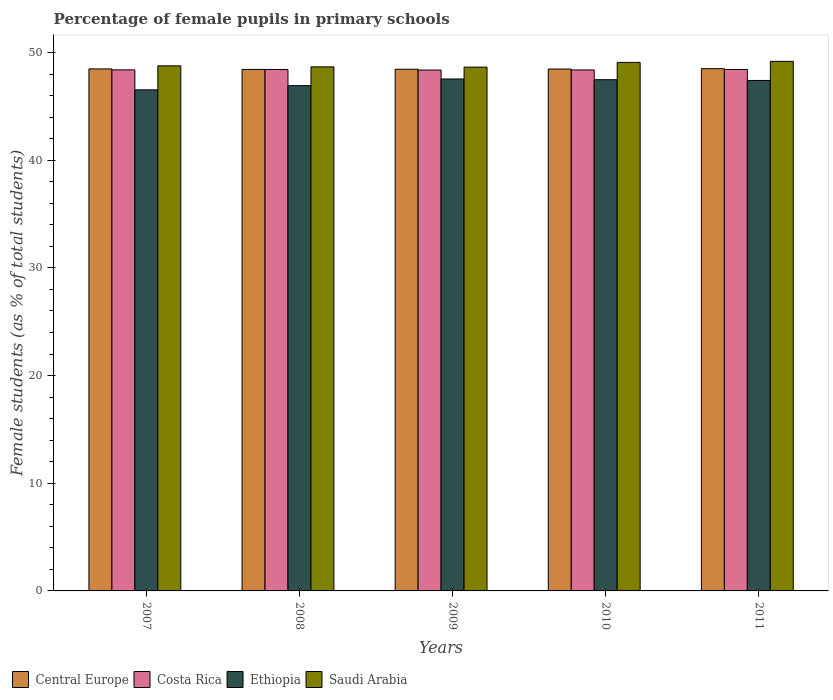How many different coloured bars are there?
Your answer should be compact. 4. How many groups of bars are there?
Make the answer very short. 5. Are the number of bars on each tick of the X-axis equal?
Ensure brevity in your answer.  Yes. In how many cases, is the number of bars for a given year not equal to the number of legend labels?
Give a very brief answer. 0. What is the percentage of female pupils in primary schools in Saudi Arabia in 2011?
Provide a succinct answer. 49.18. Across all years, what is the maximum percentage of female pupils in primary schools in Saudi Arabia?
Provide a succinct answer. 49.18. Across all years, what is the minimum percentage of female pupils in primary schools in Ethiopia?
Offer a very short reply. 46.53. In which year was the percentage of female pupils in primary schools in Central Europe maximum?
Your response must be concise. 2011. In which year was the percentage of female pupils in primary schools in Saudi Arabia minimum?
Keep it short and to the point. 2009. What is the total percentage of female pupils in primary schools in Costa Rica in the graph?
Offer a very short reply. 241.98. What is the difference between the percentage of female pupils in primary schools in Central Europe in 2009 and that in 2010?
Provide a short and direct response. -0.02. What is the difference between the percentage of female pupils in primary schools in Saudi Arabia in 2007 and the percentage of female pupils in primary schools in Central Europe in 2008?
Your response must be concise. 0.34. What is the average percentage of female pupils in primary schools in Ethiopia per year?
Ensure brevity in your answer.  47.17. In the year 2010, what is the difference between the percentage of female pupils in primary schools in Ethiopia and percentage of female pupils in primary schools in Costa Rica?
Offer a very short reply. -0.9. In how many years, is the percentage of female pupils in primary schools in Saudi Arabia greater than 40 %?
Your answer should be compact. 5. What is the ratio of the percentage of female pupils in primary schools in Costa Rica in 2010 to that in 2011?
Ensure brevity in your answer.  1. Is the difference between the percentage of female pupils in primary schools in Ethiopia in 2008 and 2009 greater than the difference between the percentage of female pupils in primary schools in Costa Rica in 2008 and 2009?
Give a very brief answer. No. What is the difference between the highest and the second highest percentage of female pupils in primary schools in Central Europe?
Your response must be concise. 0.02. What is the difference between the highest and the lowest percentage of female pupils in primary schools in Costa Rica?
Your answer should be compact. 0.05. In how many years, is the percentage of female pupils in primary schools in Saudi Arabia greater than the average percentage of female pupils in primary schools in Saudi Arabia taken over all years?
Ensure brevity in your answer.  2. Is the sum of the percentage of female pupils in primary schools in Central Europe in 2008 and 2009 greater than the maximum percentage of female pupils in primary schools in Saudi Arabia across all years?
Ensure brevity in your answer.  Yes. Is it the case that in every year, the sum of the percentage of female pupils in primary schools in Saudi Arabia and percentage of female pupils in primary schools in Costa Rica is greater than the sum of percentage of female pupils in primary schools in Central Europe and percentage of female pupils in primary schools in Ethiopia?
Provide a short and direct response. Yes. What does the 4th bar from the left in 2008 represents?
Give a very brief answer. Saudi Arabia. Is it the case that in every year, the sum of the percentage of female pupils in primary schools in Central Europe and percentage of female pupils in primary schools in Saudi Arabia is greater than the percentage of female pupils in primary schools in Ethiopia?
Offer a very short reply. Yes. What is the difference between two consecutive major ticks on the Y-axis?
Provide a succinct answer. 10. Does the graph contain grids?
Ensure brevity in your answer.  No. How many legend labels are there?
Your response must be concise. 4. How are the legend labels stacked?
Offer a terse response. Horizontal. What is the title of the graph?
Your answer should be compact. Percentage of female pupils in primary schools. Does "Mexico" appear as one of the legend labels in the graph?
Provide a succinct answer. No. What is the label or title of the Y-axis?
Your response must be concise. Female students (as % of total students). What is the Female students (as % of total students) in Central Europe in 2007?
Ensure brevity in your answer.  48.47. What is the Female students (as % of total students) of Costa Rica in 2007?
Your answer should be compact. 48.39. What is the Female students (as % of total students) of Ethiopia in 2007?
Keep it short and to the point. 46.53. What is the Female students (as % of total students) of Saudi Arabia in 2007?
Your answer should be very brief. 48.76. What is the Female students (as % of total students) in Central Europe in 2008?
Your response must be concise. 48.42. What is the Female students (as % of total students) of Costa Rica in 2008?
Offer a terse response. 48.42. What is the Female students (as % of total students) of Ethiopia in 2008?
Keep it short and to the point. 46.92. What is the Female students (as % of total students) in Saudi Arabia in 2008?
Offer a terse response. 48.66. What is the Female students (as % of total students) in Central Europe in 2009?
Your answer should be very brief. 48.44. What is the Female students (as % of total students) of Costa Rica in 2009?
Your answer should be compact. 48.37. What is the Female students (as % of total students) in Ethiopia in 2009?
Your answer should be very brief. 47.54. What is the Female students (as % of total students) in Saudi Arabia in 2009?
Offer a very short reply. 48.64. What is the Female students (as % of total students) in Central Europe in 2010?
Provide a succinct answer. 48.46. What is the Female students (as % of total students) of Costa Rica in 2010?
Your answer should be very brief. 48.38. What is the Female students (as % of total students) of Ethiopia in 2010?
Your response must be concise. 47.47. What is the Female students (as % of total students) in Saudi Arabia in 2010?
Your response must be concise. 49.08. What is the Female students (as % of total students) of Central Europe in 2011?
Offer a terse response. 48.5. What is the Female students (as % of total students) of Costa Rica in 2011?
Provide a succinct answer. 48.42. What is the Female students (as % of total students) of Ethiopia in 2011?
Your response must be concise. 47.4. What is the Female students (as % of total students) of Saudi Arabia in 2011?
Make the answer very short. 49.18. Across all years, what is the maximum Female students (as % of total students) in Central Europe?
Your answer should be compact. 48.5. Across all years, what is the maximum Female students (as % of total students) of Costa Rica?
Give a very brief answer. 48.42. Across all years, what is the maximum Female students (as % of total students) in Ethiopia?
Keep it short and to the point. 47.54. Across all years, what is the maximum Female students (as % of total students) in Saudi Arabia?
Offer a very short reply. 49.18. Across all years, what is the minimum Female students (as % of total students) of Central Europe?
Offer a terse response. 48.42. Across all years, what is the minimum Female students (as % of total students) in Costa Rica?
Your response must be concise. 48.37. Across all years, what is the minimum Female students (as % of total students) of Ethiopia?
Provide a succinct answer. 46.53. Across all years, what is the minimum Female students (as % of total students) of Saudi Arabia?
Your answer should be compact. 48.64. What is the total Female students (as % of total students) in Central Europe in the graph?
Give a very brief answer. 242.3. What is the total Female students (as % of total students) of Costa Rica in the graph?
Provide a succinct answer. 241.98. What is the total Female students (as % of total students) in Ethiopia in the graph?
Offer a very short reply. 235.87. What is the total Female students (as % of total students) of Saudi Arabia in the graph?
Make the answer very short. 244.32. What is the difference between the Female students (as % of total students) of Central Europe in 2007 and that in 2008?
Your answer should be very brief. 0.05. What is the difference between the Female students (as % of total students) of Costa Rica in 2007 and that in 2008?
Your answer should be compact. -0.04. What is the difference between the Female students (as % of total students) of Ethiopia in 2007 and that in 2008?
Give a very brief answer. -0.39. What is the difference between the Female students (as % of total students) of Saudi Arabia in 2007 and that in 2008?
Your answer should be compact. 0.1. What is the difference between the Female students (as % of total students) of Central Europe in 2007 and that in 2009?
Offer a terse response. 0.03. What is the difference between the Female students (as % of total students) of Costa Rica in 2007 and that in 2009?
Give a very brief answer. 0.01. What is the difference between the Female students (as % of total students) of Ethiopia in 2007 and that in 2009?
Your answer should be very brief. -1.01. What is the difference between the Female students (as % of total students) of Saudi Arabia in 2007 and that in 2009?
Provide a short and direct response. 0.12. What is the difference between the Female students (as % of total students) in Central Europe in 2007 and that in 2010?
Provide a short and direct response. 0.01. What is the difference between the Female students (as % of total students) of Costa Rica in 2007 and that in 2010?
Give a very brief answer. 0.01. What is the difference between the Female students (as % of total students) in Ethiopia in 2007 and that in 2010?
Ensure brevity in your answer.  -0.94. What is the difference between the Female students (as % of total students) in Saudi Arabia in 2007 and that in 2010?
Provide a short and direct response. -0.32. What is the difference between the Female students (as % of total students) of Central Europe in 2007 and that in 2011?
Your answer should be compact. -0.02. What is the difference between the Female students (as % of total students) in Costa Rica in 2007 and that in 2011?
Give a very brief answer. -0.04. What is the difference between the Female students (as % of total students) of Ethiopia in 2007 and that in 2011?
Ensure brevity in your answer.  -0.87. What is the difference between the Female students (as % of total students) of Saudi Arabia in 2007 and that in 2011?
Your response must be concise. -0.42. What is the difference between the Female students (as % of total students) in Central Europe in 2008 and that in 2009?
Your answer should be compact. -0.02. What is the difference between the Female students (as % of total students) in Costa Rica in 2008 and that in 2009?
Provide a succinct answer. 0.05. What is the difference between the Female students (as % of total students) in Ethiopia in 2008 and that in 2009?
Make the answer very short. -0.62. What is the difference between the Female students (as % of total students) of Saudi Arabia in 2008 and that in 2009?
Offer a terse response. 0.02. What is the difference between the Female students (as % of total students) in Central Europe in 2008 and that in 2010?
Offer a very short reply. -0.04. What is the difference between the Female students (as % of total students) in Costa Rica in 2008 and that in 2010?
Your answer should be compact. 0.05. What is the difference between the Female students (as % of total students) in Ethiopia in 2008 and that in 2010?
Provide a short and direct response. -0.55. What is the difference between the Female students (as % of total students) in Saudi Arabia in 2008 and that in 2010?
Provide a succinct answer. -0.42. What is the difference between the Female students (as % of total students) in Central Europe in 2008 and that in 2011?
Your response must be concise. -0.07. What is the difference between the Female students (as % of total students) of Costa Rica in 2008 and that in 2011?
Offer a terse response. 0. What is the difference between the Female students (as % of total students) of Ethiopia in 2008 and that in 2011?
Ensure brevity in your answer.  -0.48. What is the difference between the Female students (as % of total students) of Saudi Arabia in 2008 and that in 2011?
Offer a very short reply. -0.51. What is the difference between the Female students (as % of total students) of Central Europe in 2009 and that in 2010?
Your answer should be very brief. -0.02. What is the difference between the Female students (as % of total students) in Costa Rica in 2009 and that in 2010?
Keep it short and to the point. -0.01. What is the difference between the Female students (as % of total students) in Ethiopia in 2009 and that in 2010?
Make the answer very short. 0.07. What is the difference between the Female students (as % of total students) in Saudi Arabia in 2009 and that in 2010?
Make the answer very short. -0.44. What is the difference between the Female students (as % of total students) in Central Europe in 2009 and that in 2011?
Your answer should be compact. -0.05. What is the difference between the Female students (as % of total students) in Costa Rica in 2009 and that in 2011?
Give a very brief answer. -0.05. What is the difference between the Female students (as % of total students) of Ethiopia in 2009 and that in 2011?
Your response must be concise. 0.14. What is the difference between the Female students (as % of total students) of Saudi Arabia in 2009 and that in 2011?
Offer a very short reply. -0.54. What is the difference between the Female students (as % of total students) in Central Europe in 2010 and that in 2011?
Offer a very short reply. -0.03. What is the difference between the Female students (as % of total students) of Costa Rica in 2010 and that in 2011?
Your answer should be compact. -0.04. What is the difference between the Female students (as % of total students) of Ethiopia in 2010 and that in 2011?
Offer a very short reply. 0.07. What is the difference between the Female students (as % of total students) in Saudi Arabia in 2010 and that in 2011?
Your response must be concise. -0.1. What is the difference between the Female students (as % of total students) of Central Europe in 2007 and the Female students (as % of total students) of Costa Rica in 2008?
Your response must be concise. 0.05. What is the difference between the Female students (as % of total students) in Central Europe in 2007 and the Female students (as % of total students) in Ethiopia in 2008?
Your response must be concise. 1.55. What is the difference between the Female students (as % of total students) of Central Europe in 2007 and the Female students (as % of total students) of Saudi Arabia in 2008?
Keep it short and to the point. -0.19. What is the difference between the Female students (as % of total students) in Costa Rica in 2007 and the Female students (as % of total students) in Ethiopia in 2008?
Your response must be concise. 1.47. What is the difference between the Female students (as % of total students) in Costa Rica in 2007 and the Female students (as % of total students) in Saudi Arabia in 2008?
Give a very brief answer. -0.28. What is the difference between the Female students (as % of total students) in Ethiopia in 2007 and the Female students (as % of total students) in Saudi Arabia in 2008?
Provide a succinct answer. -2.13. What is the difference between the Female students (as % of total students) in Central Europe in 2007 and the Female students (as % of total students) in Costa Rica in 2009?
Ensure brevity in your answer.  0.1. What is the difference between the Female students (as % of total students) of Central Europe in 2007 and the Female students (as % of total students) of Ethiopia in 2009?
Your answer should be very brief. 0.93. What is the difference between the Female students (as % of total students) in Central Europe in 2007 and the Female students (as % of total students) in Saudi Arabia in 2009?
Ensure brevity in your answer.  -0.17. What is the difference between the Female students (as % of total students) in Costa Rica in 2007 and the Female students (as % of total students) in Ethiopia in 2009?
Ensure brevity in your answer.  0.85. What is the difference between the Female students (as % of total students) in Costa Rica in 2007 and the Female students (as % of total students) in Saudi Arabia in 2009?
Offer a very short reply. -0.26. What is the difference between the Female students (as % of total students) in Ethiopia in 2007 and the Female students (as % of total students) in Saudi Arabia in 2009?
Offer a very short reply. -2.11. What is the difference between the Female students (as % of total students) of Central Europe in 2007 and the Female students (as % of total students) of Costa Rica in 2010?
Ensure brevity in your answer.  0.1. What is the difference between the Female students (as % of total students) of Central Europe in 2007 and the Female students (as % of total students) of Ethiopia in 2010?
Keep it short and to the point. 1. What is the difference between the Female students (as % of total students) in Central Europe in 2007 and the Female students (as % of total students) in Saudi Arabia in 2010?
Make the answer very short. -0.61. What is the difference between the Female students (as % of total students) in Costa Rica in 2007 and the Female students (as % of total students) in Ethiopia in 2010?
Your answer should be very brief. 0.91. What is the difference between the Female students (as % of total students) of Costa Rica in 2007 and the Female students (as % of total students) of Saudi Arabia in 2010?
Your answer should be compact. -0.69. What is the difference between the Female students (as % of total students) of Ethiopia in 2007 and the Female students (as % of total students) of Saudi Arabia in 2010?
Your answer should be compact. -2.55. What is the difference between the Female students (as % of total students) of Central Europe in 2007 and the Female students (as % of total students) of Costa Rica in 2011?
Your answer should be very brief. 0.05. What is the difference between the Female students (as % of total students) of Central Europe in 2007 and the Female students (as % of total students) of Ethiopia in 2011?
Your answer should be very brief. 1.07. What is the difference between the Female students (as % of total students) of Central Europe in 2007 and the Female students (as % of total students) of Saudi Arabia in 2011?
Ensure brevity in your answer.  -0.7. What is the difference between the Female students (as % of total students) of Costa Rica in 2007 and the Female students (as % of total students) of Ethiopia in 2011?
Provide a succinct answer. 0.98. What is the difference between the Female students (as % of total students) of Costa Rica in 2007 and the Female students (as % of total students) of Saudi Arabia in 2011?
Keep it short and to the point. -0.79. What is the difference between the Female students (as % of total students) in Ethiopia in 2007 and the Female students (as % of total students) in Saudi Arabia in 2011?
Your response must be concise. -2.64. What is the difference between the Female students (as % of total students) in Central Europe in 2008 and the Female students (as % of total students) in Costa Rica in 2009?
Make the answer very short. 0.05. What is the difference between the Female students (as % of total students) in Central Europe in 2008 and the Female students (as % of total students) in Ethiopia in 2009?
Make the answer very short. 0.88. What is the difference between the Female students (as % of total students) in Central Europe in 2008 and the Female students (as % of total students) in Saudi Arabia in 2009?
Give a very brief answer. -0.22. What is the difference between the Female students (as % of total students) in Costa Rica in 2008 and the Female students (as % of total students) in Ethiopia in 2009?
Offer a terse response. 0.88. What is the difference between the Female students (as % of total students) in Costa Rica in 2008 and the Female students (as % of total students) in Saudi Arabia in 2009?
Keep it short and to the point. -0.22. What is the difference between the Female students (as % of total students) in Ethiopia in 2008 and the Female students (as % of total students) in Saudi Arabia in 2009?
Offer a very short reply. -1.72. What is the difference between the Female students (as % of total students) in Central Europe in 2008 and the Female students (as % of total students) in Costa Rica in 2010?
Keep it short and to the point. 0.05. What is the difference between the Female students (as % of total students) of Central Europe in 2008 and the Female students (as % of total students) of Ethiopia in 2010?
Your answer should be compact. 0.95. What is the difference between the Female students (as % of total students) in Central Europe in 2008 and the Female students (as % of total students) in Saudi Arabia in 2010?
Provide a succinct answer. -0.65. What is the difference between the Female students (as % of total students) in Costa Rica in 2008 and the Female students (as % of total students) in Ethiopia in 2010?
Your answer should be very brief. 0.95. What is the difference between the Female students (as % of total students) in Costa Rica in 2008 and the Female students (as % of total students) in Saudi Arabia in 2010?
Your answer should be compact. -0.66. What is the difference between the Female students (as % of total students) in Ethiopia in 2008 and the Female students (as % of total students) in Saudi Arabia in 2010?
Your answer should be very brief. -2.16. What is the difference between the Female students (as % of total students) in Central Europe in 2008 and the Female students (as % of total students) in Costa Rica in 2011?
Offer a very short reply. 0. What is the difference between the Female students (as % of total students) of Central Europe in 2008 and the Female students (as % of total students) of Ethiopia in 2011?
Your response must be concise. 1.02. What is the difference between the Female students (as % of total students) of Central Europe in 2008 and the Female students (as % of total students) of Saudi Arabia in 2011?
Your answer should be compact. -0.75. What is the difference between the Female students (as % of total students) in Costa Rica in 2008 and the Female students (as % of total students) in Ethiopia in 2011?
Your answer should be compact. 1.02. What is the difference between the Female students (as % of total students) of Costa Rica in 2008 and the Female students (as % of total students) of Saudi Arabia in 2011?
Your response must be concise. -0.75. What is the difference between the Female students (as % of total students) in Ethiopia in 2008 and the Female students (as % of total students) in Saudi Arabia in 2011?
Offer a terse response. -2.26. What is the difference between the Female students (as % of total students) of Central Europe in 2009 and the Female students (as % of total students) of Costa Rica in 2010?
Provide a succinct answer. 0.07. What is the difference between the Female students (as % of total students) of Central Europe in 2009 and the Female students (as % of total students) of Ethiopia in 2010?
Your response must be concise. 0.97. What is the difference between the Female students (as % of total students) in Central Europe in 2009 and the Female students (as % of total students) in Saudi Arabia in 2010?
Your answer should be very brief. -0.64. What is the difference between the Female students (as % of total students) of Costa Rica in 2009 and the Female students (as % of total students) of Ethiopia in 2010?
Your answer should be compact. 0.9. What is the difference between the Female students (as % of total students) in Costa Rica in 2009 and the Female students (as % of total students) in Saudi Arabia in 2010?
Your response must be concise. -0.71. What is the difference between the Female students (as % of total students) of Ethiopia in 2009 and the Female students (as % of total students) of Saudi Arabia in 2010?
Your answer should be compact. -1.54. What is the difference between the Female students (as % of total students) in Central Europe in 2009 and the Female students (as % of total students) in Costa Rica in 2011?
Ensure brevity in your answer.  0.02. What is the difference between the Female students (as % of total students) of Central Europe in 2009 and the Female students (as % of total students) of Ethiopia in 2011?
Your response must be concise. 1.04. What is the difference between the Female students (as % of total students) of Central Europe in 2009 and the Female students (as % of total students) of Saudi Arabia in 2011?
Offer a very short reply. -0.73. What is the difference between the Female students (as % of total students) in Costa Rica in 2009 and the Female students (as % of total students) in Ethiopia in 2011?
Give a very brief answer. 0.97. What is the difference between the Female students (as % of total students) of Costa Rica in 2009 and the Female students (as % of total students) of Saudi Arabia in 2011?
Provide a short and direct response. -0.81. What is the difference between the Female students (as % of total students) of Ethiopia in 2009 and the Female students (as % of total students) of Saudi Arabia in 2011?
Provide a short and direct response. -1.64. What is the difference between the Female students (as % of total students) of Central Europe in 2010 and the Female students (as % of total students) of Costa Rica in 2011?
Give a very brief answer. 0.04. What is the difference between the Female students (as % of total students) in Central Europe in 2010 and the Female students (as % of total students) in Ethiopia in 2011?
Ensure brevity in your answer.  1.06. What is the difference between the Female students (as % of total students) in Central Europe in 2010 and the Female students (as % of total students) in Saudi Arabia in 2011?
Offer a very short reply. -0.71. What is the difference between the Female students (as % of total students) of Costa Rica in 2010 and the Female students (as % of total students) of Saudi Arabia in 2011?
Provide a succinct answer. -0.8. What is the difference between the Female students (as % of total students) of Ethiopia in 2010 and the Female students (as % of total students) of Saudi Arabia in 2011?
Your answer should be compact. -1.7. What is the average Female students (as % of total students) of Central Europe per year?
Provide a short and direct response. 48.46. What is the average Female students (as % of total students) of Costa Rica per year?
Your response must be concise. 48.4. What is the average Female students (as % of total students) of Ethiopia per year?
Provide a succinct answer. 47.17. What is the average Female students (as % of total students) of Saudi Arabia per year?
Your answer should be very brief. 48.86. In the year 2007, what is the difference between the Female students (as % of total students) in Central Europe and Female students (as % of total students) in Costa Rica?
Keep it short and to the point. 0.09. In the year 2007, what is the difference between the Female students (as % of total students) in Central Europe and Female students (as % of total students) in Ethiopia?
Give a very brief answer. 1.94. In the year 2007, what is the difference between the Female students (as % of total students) in Central Europe and Female students (as % of total students) in Saudi Arabia?
Keep it short and to the point. -0.29. In the year 2007, what is the difference between the Female students (as % of total students) in Costa Rica and Female students (as % of total students) in Ethiopia?
Your answer should be compact. 1.85. In the year 2007, what is the difference between the Female students (as % of total students) in Costa Rica and Female students (as % of total students) in Saudi Arabia?
Make the answer very short. -0.37. In the year 2007, what is the difference between the Female students (as % of total students) of Ethiopia and Female students (as % of total students) of Saudi Arabia?
Offer a very short reply. -2.23. In the year 2008, what is the difference between the Female students (as % of total students) in Central Europe and Female students (as % of total students) in Costa Rica?
Offer a terse response. 0. In the year 2008, what is the difference between the Female students (as % of total students) in Central Europe and Female students (as % of total students) in Ethiopia?
Give a very brief answer. 1.51. In the year 2008, what is the difference between the Female students (as % of total students) of Central Europe and Female students (as % of total students) of Saudi Arabia?
Provide a short and direct response. -0.24. In the year 2008, what is the difference between the Female students (as % of total students) of Costa Rica and Female students (as % of total students) of Ethiopia?
Offer a very short reply. 1.5. In the year 2008, what is the difference between the Female students (as % of total students) in Costa Rica and Female students (as % of total students) in Saudi Arabia?
Your answer should be compact. -0.24. In the year 2008, what is the difference between the Female students (as % of total students) of Ethiopia and Female students (as % of total students) of Saudi Arabia?
Offer a very short reply. -1.74. In the year 2009, what is the difference between the Female students (as % of total students) in Central Europe and Female students (as % of total students) in Costa Rica?
Give a very brief answer. 0.07. In the year 2009, what is the difference between the Female students (as % of total students) of Central Europe and Female students (as % of total students) of Ethiopia?
Provide a succinct answer. 0.9. In the year 2009, what is the difference between the Female students (as % of total students) in Central Europe and Female students (as % of total students) in Saudi Arabia?
Ensure brevity in your answer.  -0.2. In the year 2009, what is the difference between the Female students (as % of total students) of Costa Rica and Female students (as % of total students) of Ethiopia?
Your response must be concise. 0.83. In the year 2009, what is the difference between the Female students (as % of total students) of Costa Rica and Female students (as % of total students) of Saudi Arabia?
Provide a succinct answer. -0.27. In the year 2009, what is the difference between the Female students (as % of total students) of Ethiopia and Female students (as % of total students) of Saudi Arabia?
Provide a short and direct response. -1.1. In the year 2010, what is the difference between the Female students (as % of total students) of Central Europe and Female students (as % of total students) of Costa Rica?
Give a very brief answer. 0.09. In the year 2010, what is the difference between the Female students (as % of total students) in Central Europe and Female students (as % of total students) in Saudi Arabia?
Make the answer very short. -0.62. In the year 2010, what is the difference between the Female students (as % of total students) of Costa Rica and Female students (as % of total students) of Ethiopia?
Your response must be concise. 0.9. In the year 2010, what is the difference between the Female students (as % of total students) in Costa Rica and Female students (as % of total students) in Saudi Arabia?
Offer a terse response. -0.7. In the year 2010, what is the difference between the Female students (as % of total students) in Ethiopia and Female students (as % of total students) in Saudi Arabia?
Keep it short and to the point. -1.61. In the year 2011, what is the difference between the Female students (as % of total students) in Central Europe and Female students (as % of total students) in Costa Rica?
Keep it short and to the point. 0.07. In the year 2011, what is the difference between the Female students (as % of total students) in Central Europe and Female students (as % of total students) in Ethiopia?
Ensure brevity in your answer.  1.09. In the year 2011, what is the difference between the Female students (as % of total students) of Central Europe and Female students (as % of total students) of Saudi Arabia?
Make the answer very short. -0.68. In the year 2011, what is the difference between the Female students (as % of total students) in Costa Rica and Female students (as % of total students) in Ethiopia?
Keep it short and to the point. 1.02. In the year 2011, what is the difference between the Female students (as % of total students) of Costa Rica and Female students (as % of total students) of Saudi Arabia?
Keep it short and to the point. -0.75. In the year 2011, what is the difference between the Female students (as % of total students) of Ethiopia and Female students (as % of total students) of Saudi Arabia?
Keep it short and to the point. -1.77. What is the ratio of the Female students (as % of total students) in Central Europe in 2007 to that in 2008?
Your answer should be very brief. 1. What is the ratio of the Female students (as % of total students) in Ethiopia in 2007 to that in 2008?
Keep it short and to the point. 0.99. What is the ratio of the Female students (as % of total students) in Central Europe in 2007 to that in 2009?
Keep it short and to the point. 1. What is the ratio of the Female students (as % of total students) of Costa Rica in 2007 to that in 2009?
Offer a terse response. 1. What is the ratio of the Female students (as % of total students) of Ethiopia in 2007 to that in 2009?
Your answer should be compact. 0.98. What is the ratio of the Female students (as % of total students) in Central Europe in 2007 to that in 2010?
Make the answer very short. 1. What is the ratio of the Female students (as % of total students) of Ethiopia in 2007 to that in 2010?
Offer a very short reply. 0.98. What is the ratio of the Female students (as % of total students) in Saudi Arabia in 2007 to that in 2010?
Your answer should be very brief. 0.99. What is the ratio of the Female students (as % of total students) of Ethiopia in 2007 to that in 2011?
Give a very brief answer. 0.98. What is the ratio of the Female students (as % of total students) in Costa Rica in 2008 to that in 2009?
Give a very brief answer. 1. What is the ratio of the Female students (as % of total students) of Ethiopia in 2008 to that in 2009?
Make the answer very short. 0.99. What is the ratio of the Female students (as % of total students) of Saudi Arabia in 2008 to that in 2009?
Make the answer very short. 1. What is the ratio of the Female students (as % of total students) in Central Europe in 2008 to that in 2010?
Provide a succinct answer. 1. What is the ratio of the Female students (as % of total students) in Ethiopia in 2008 to that in 2010?
Offer a very short reply. 0.99. What is the ratio of the Female students (as % of total students) in Costa Rica in 2008 to that in 2011?
Offer a terse response. 1. What is the ratio of the Female students (as % of total students) in Central Europe in 2009 to that in 2010?
Your answer should be very brief. 1. What is the ratio of the Female students (as % of total students) in Ethiopia in 2009 to that in 2010?
Your answer should be compact. 1. What is the ratio of the Female students (as % of total students) of Ethiopia in 2009 to that in 2011?
Keep it short and to the point. 1. What is the ratio of the Female students (as % of total students) in Saudi Arabia in 2009 to that in 2011?
Ensure brevity in your answer.  0.99. What is the difference between the highest and the second highest Female students (as % of total students) of Central Europe?
Make the answer very short. 0.02. What is the difference between the highest and the second highest Female students (as % of total students) in Costa Rica?
Give a very brief answer. 0. What is the difference between the highest and the second highest Female students (as % of total students) of Ethiopia?
Provide a succinct answer. 0.07. What is the difference between the highest and the second highest Female students (as % of total students) in Saudi Arabia?
Your response must be concise. 0.1. What is the difference between the highest and the lowest Female students (as % of total students) of Central Europe?
Your answer should be very brief. 0.07. What is the difference between the highest and the lowest Female students (as % of total students) in Costa Rica?
Your answer should be compact. 0.05. What is the difference between the highest and the lowest Female students (as % of total students) of Ethiopia?
Give a very brief answer. 1.01. What is the difference between the highest and the lowest Female students (as % of total students) of Saudi Arabia?
Ensure brevity in your answer.  0.54. 